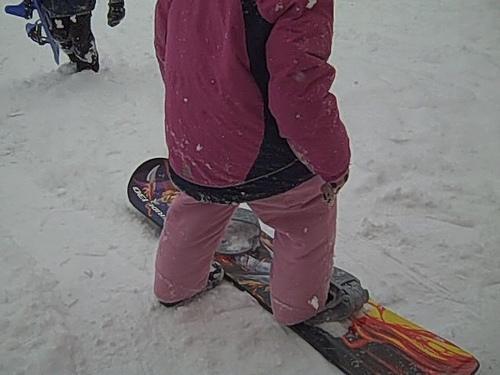How many snowboards are in the image?
Give a very brief answer. 1. 